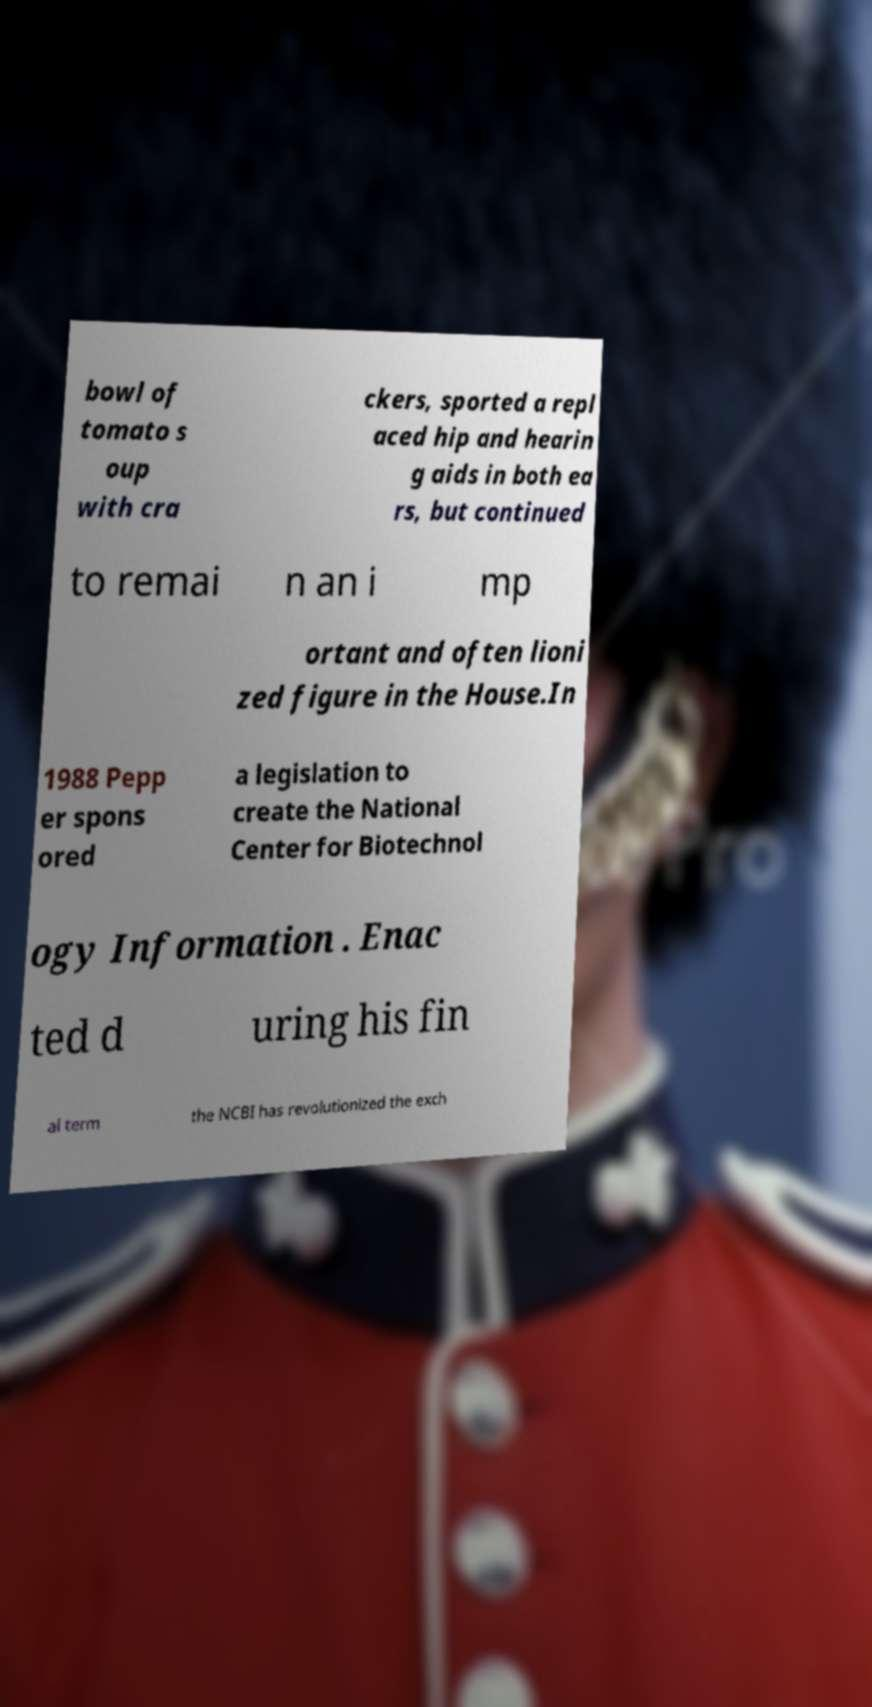There's text embedded in this image that I need extracted. Can you transcribe it verbatim? bowl of tomato s oup with cra ckers, sported a repl aced hip and hearin g aids in both ea rs, but continued to remai n an i mp ortant and often lioni zed figure in the House.In 1988 Pepp er spons ored a legislation to create the National Center for Biotechnol ogy Information . Enac ted d uring his fin al term the NCBI has revolutionized the exch 